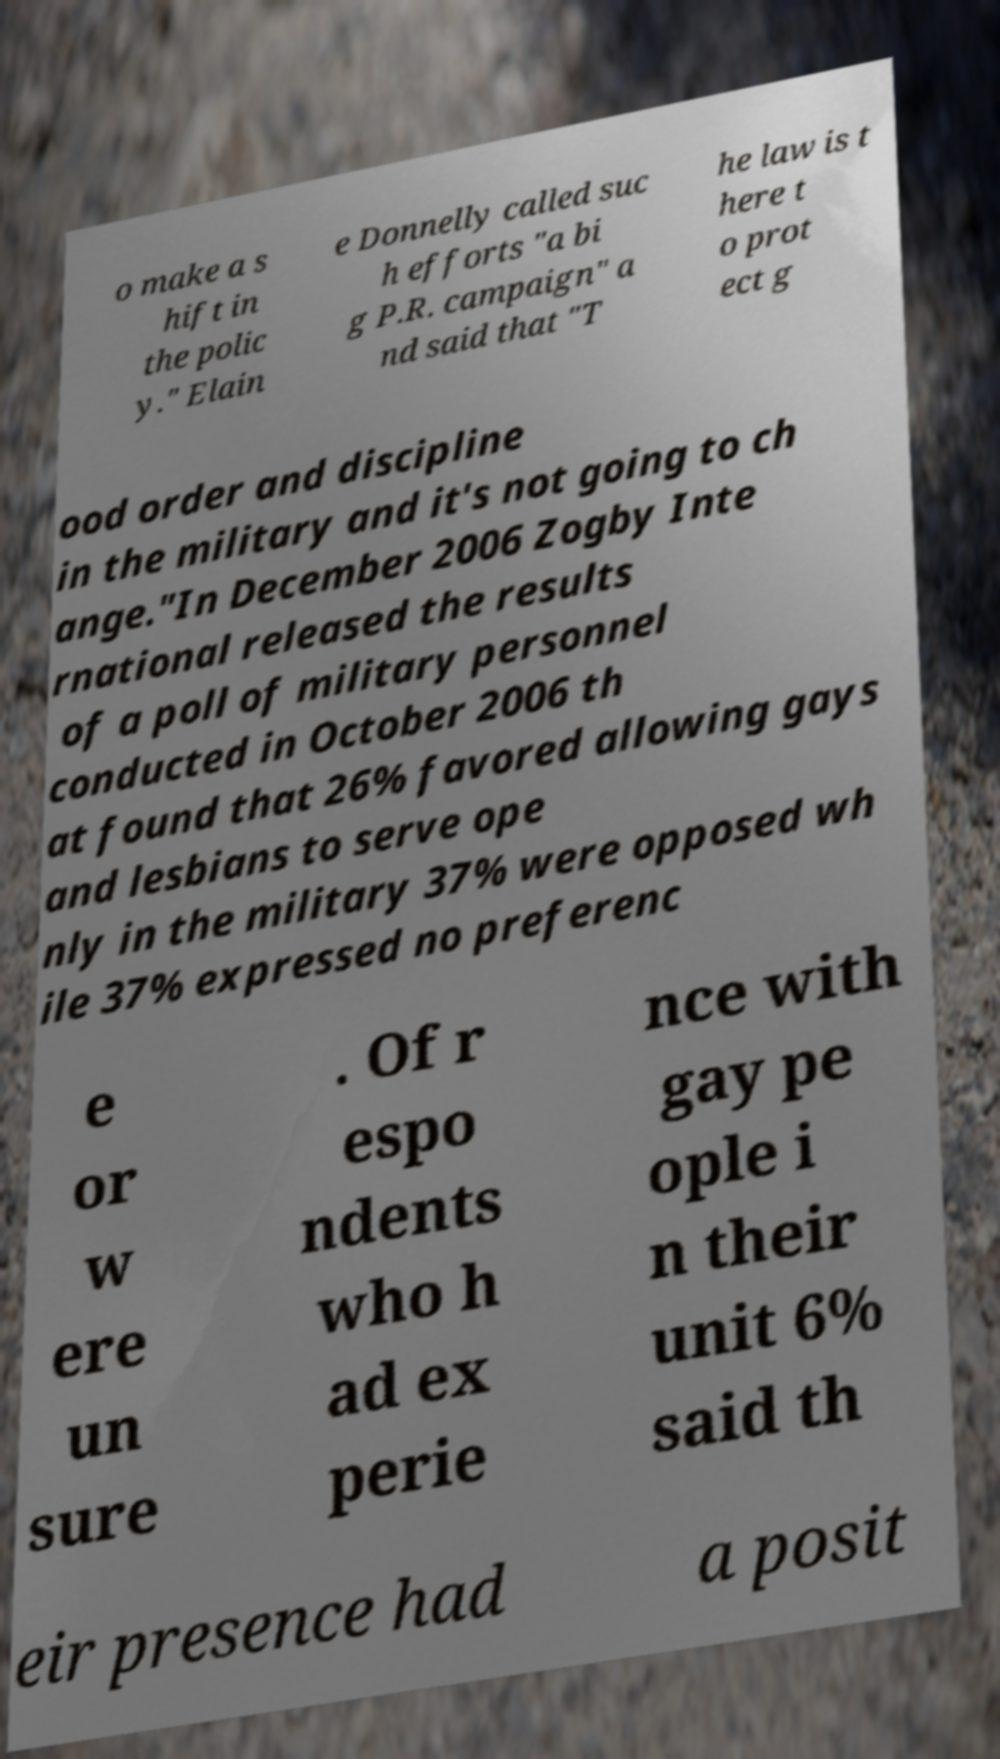Could you extract and type out the text from this image? o make a s hift in the polic y." Elain e Donnelly called suc h efforts "a bi g P.R. campaign" a nd said that "T he law is t here t o prot ect g ood order and discipline in the military and it's not going to ch ange."In December 2006 Zogby Inte rnational released the results of a poll of military personnel conducted in October 2006 th at found that 26% favored allowing gays and lesbians to serve ope nly in the military 37% were opposed wh ile 37% expressed no preferenc e or w ere un sure . Of r espo ndents who h ad ex perie nce with gay pe ople i n their unit 6% said th eir presence had a posit 